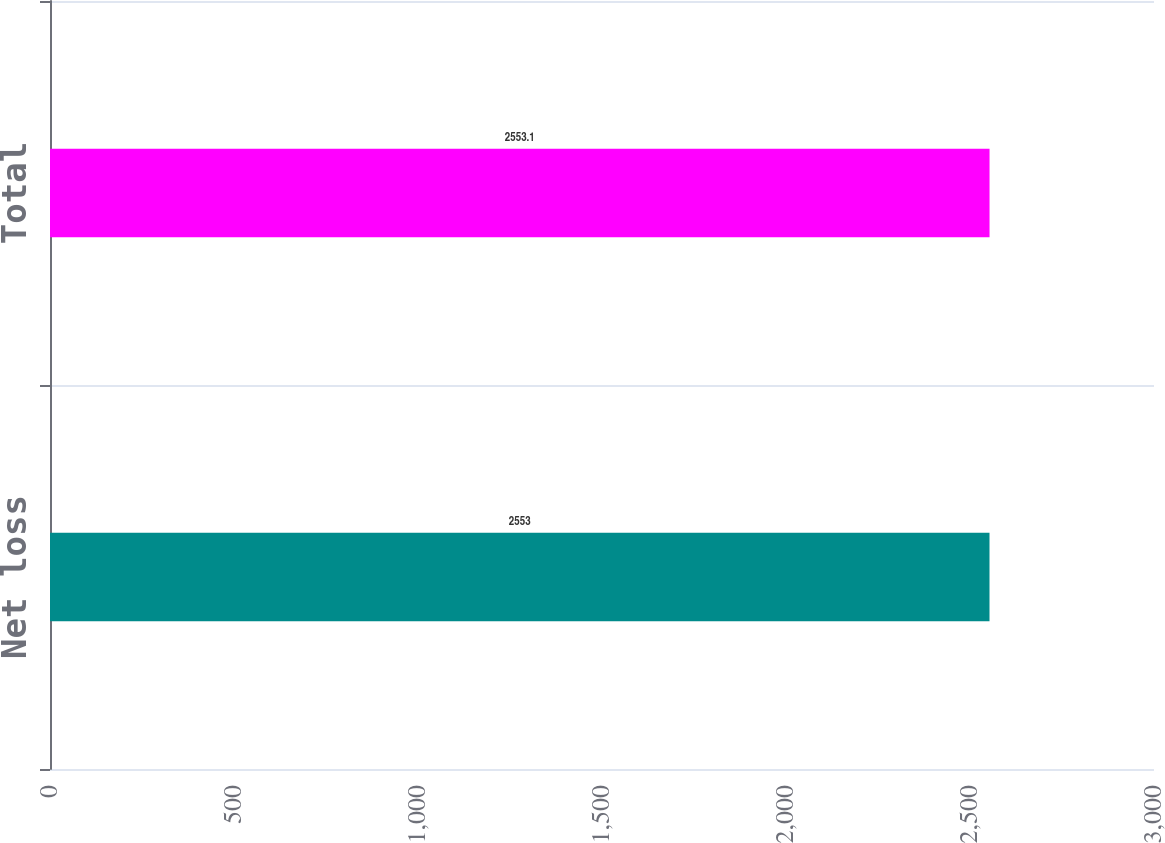<chart> <loc_0><loc_0><loc_500><loc_500><bar_chart><fcel>Net loss<fcel>Total<nl><fcel>2553<fcel>2553.1<nl></chart> 